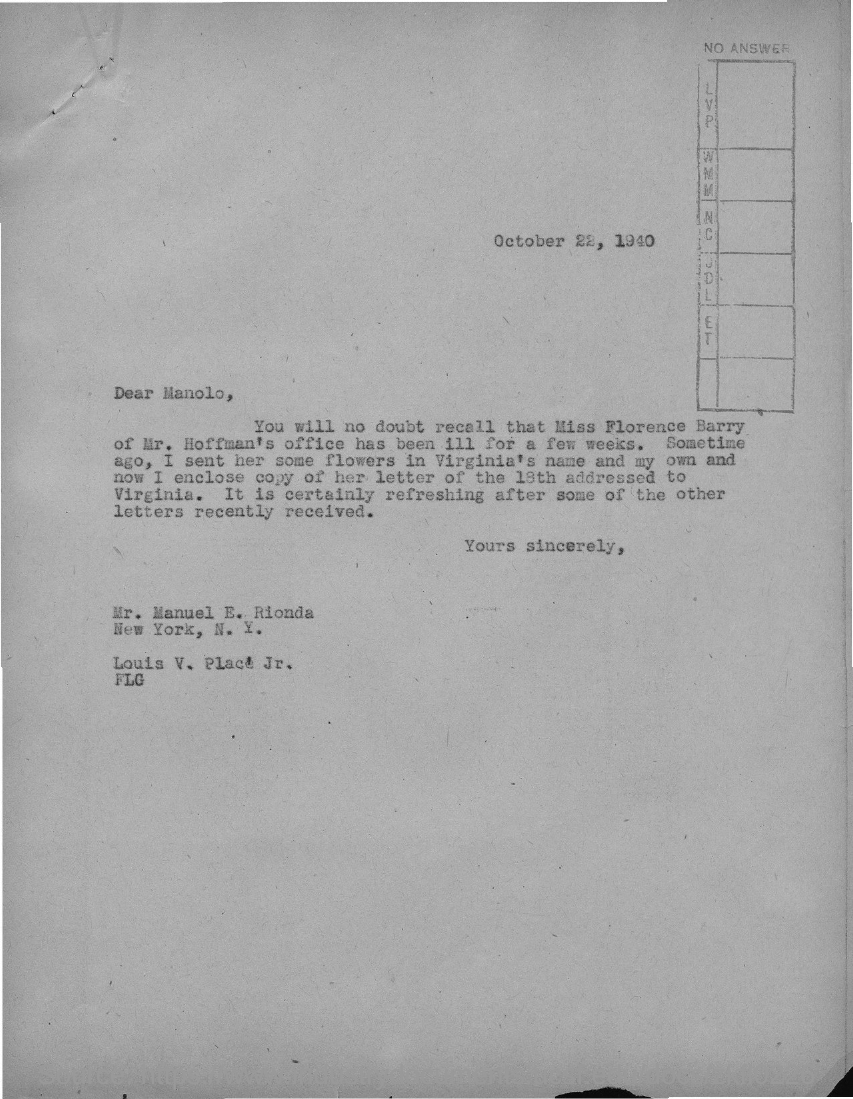Identify some key points in this picture. The date on the document is October 22, 1940. The letter is addressed to Manolo. 